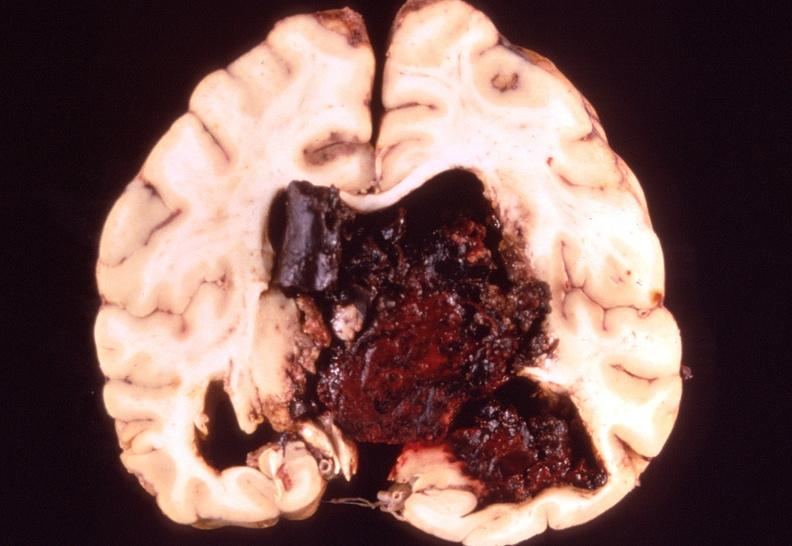does this image show brain, intracerebral hemorrhage?
Answer the question using a single word or phrase. Yes 